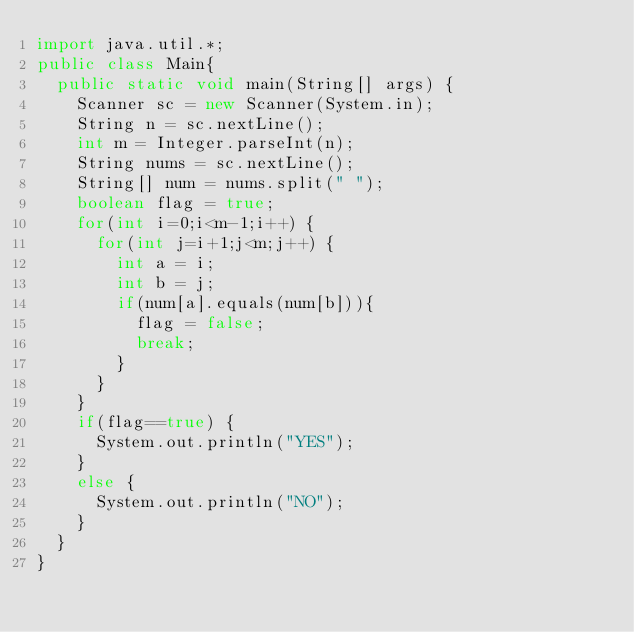Convert code to text. <code><loc_0><loc_0><loc_500><loc_500><_Java_>import java.util.*;
public class Main{
	public static void main(String[] args) {
		Scanner sc = new Scanner(System.in);
		String n = sc.nextLine();
		int m = Integer.parseInt(n);
		String nums = sc.nextLine();
		String[] num = nums.split(" ");
		boolean flag = true;
		for(int i=0;i<m-1;i++) {
			for(int j=i+1;j<m;j++) {
				int a = i;
				int b = j;
				if(num[a].equals(num[b])){
					flag = false;
					break;
				}
			}
		}
		if(flag==true) {
			System.out.println("YES");
		}
		else {
			System.out.println("NO");
		}
	}
}</code> 